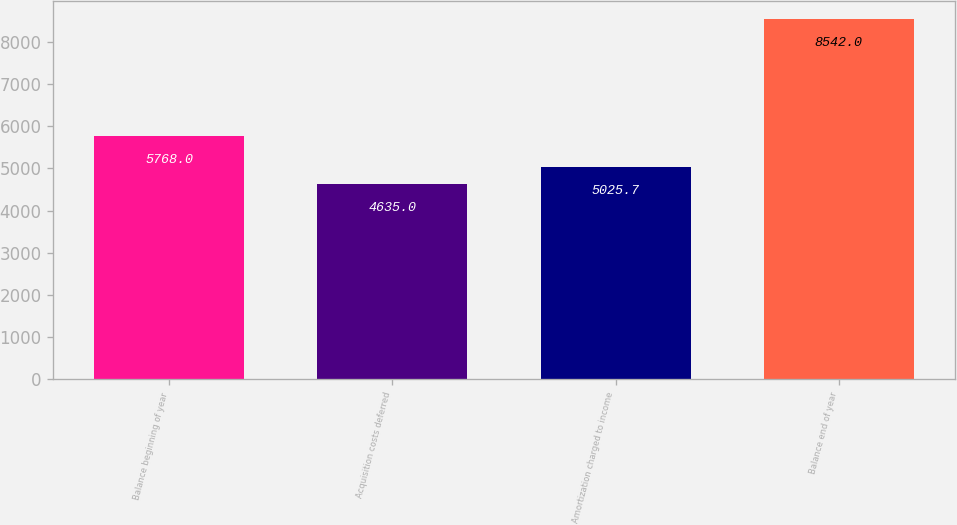Convert chart. <chart><loc_0><loc_0><loc_500><loc_500><bar_chart><fcel>Balance beginning of year<fcel>Acquisition costs deferred<fcel>Amortization charged to income<fcel>Balance end of year<nl><fcel>5768<fcel>4635<fcel>5025.7<fcel>8542<nl></chart> 